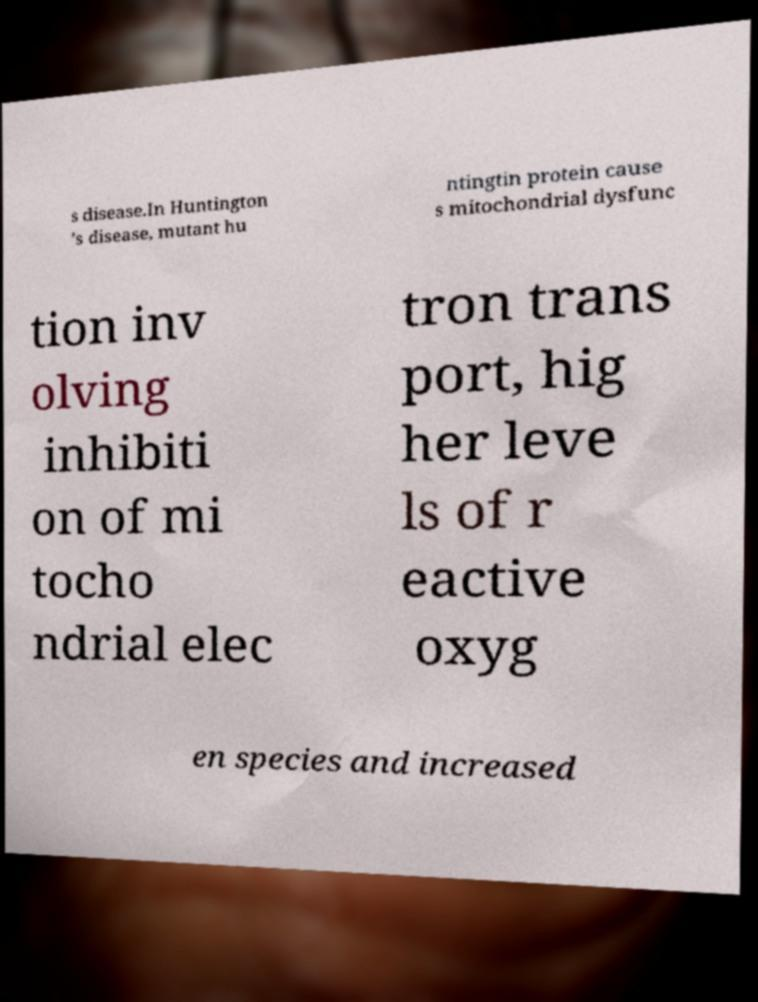I need the written content from this picture converted into text. Can you do that? s disease.In Huntington ’s disease, mutant hu ntingtin protein cause s mitochondrial dysfunc tion inv olving inhibiti on of mi tocho ndrial elec tron trans port, hig her leve ls of r eactive oxyg en species and increased 